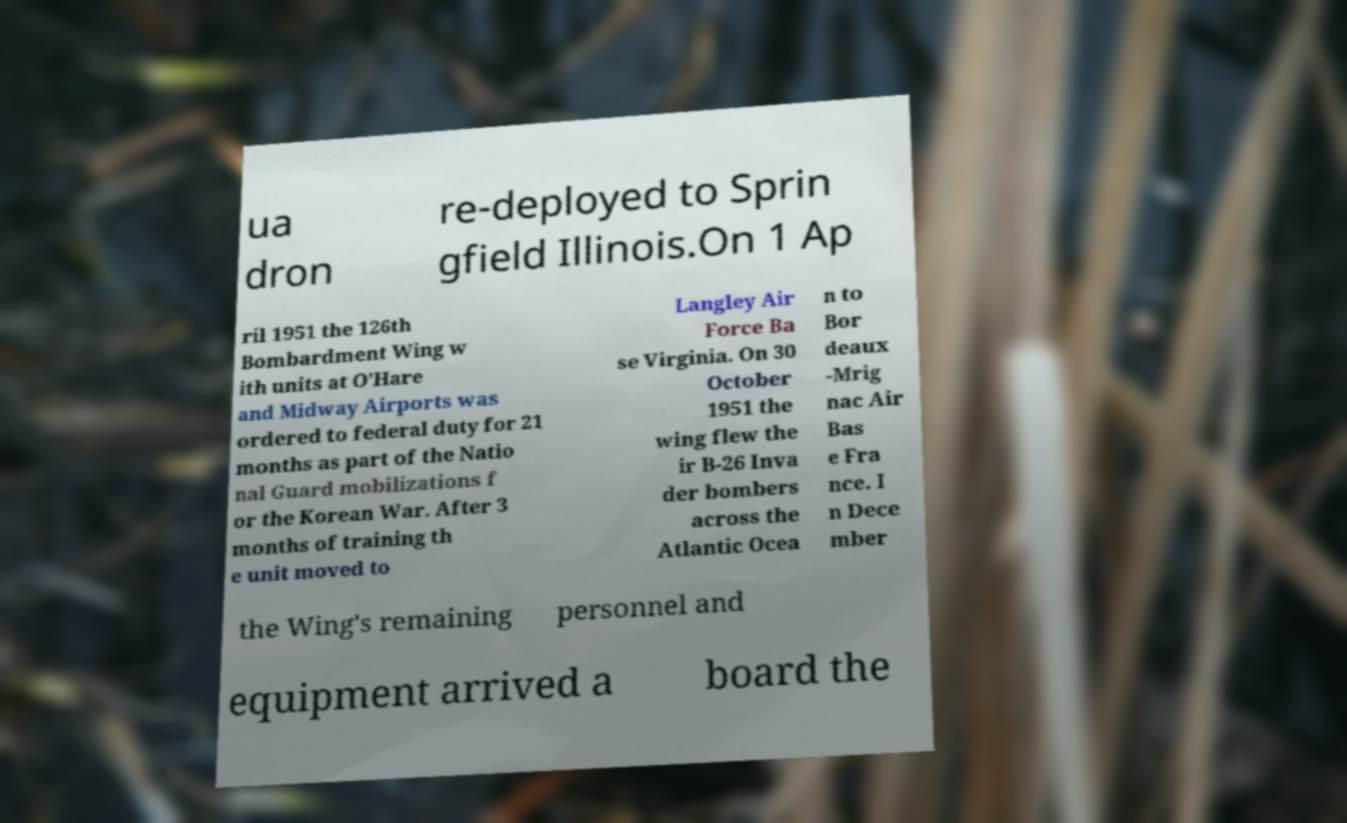There's text embedded in this image that I need extracted. Can you transcribe it verbatim? ua dron re-deployed to Sprin gfield Illinois.On 1 Ap ril 1951 the 126th Bombardment Wing w ith units at O'Hare and Midway Airports was ordered to federal duty for 21 months as part of the Natio nal Guard mobilizations f or the Korean War. After 3 months of training th e unit moved to Langley Air Force Ba se Virginia. On 30 October 1951 the wing flew the ir B-26 Inva der bombers across the Atlantic Ocea n to Bor deaux -Mrig nac Air Bas e Fra nce. I n Dece mber the Wing's remaining personnel and equipment arrived a board the 